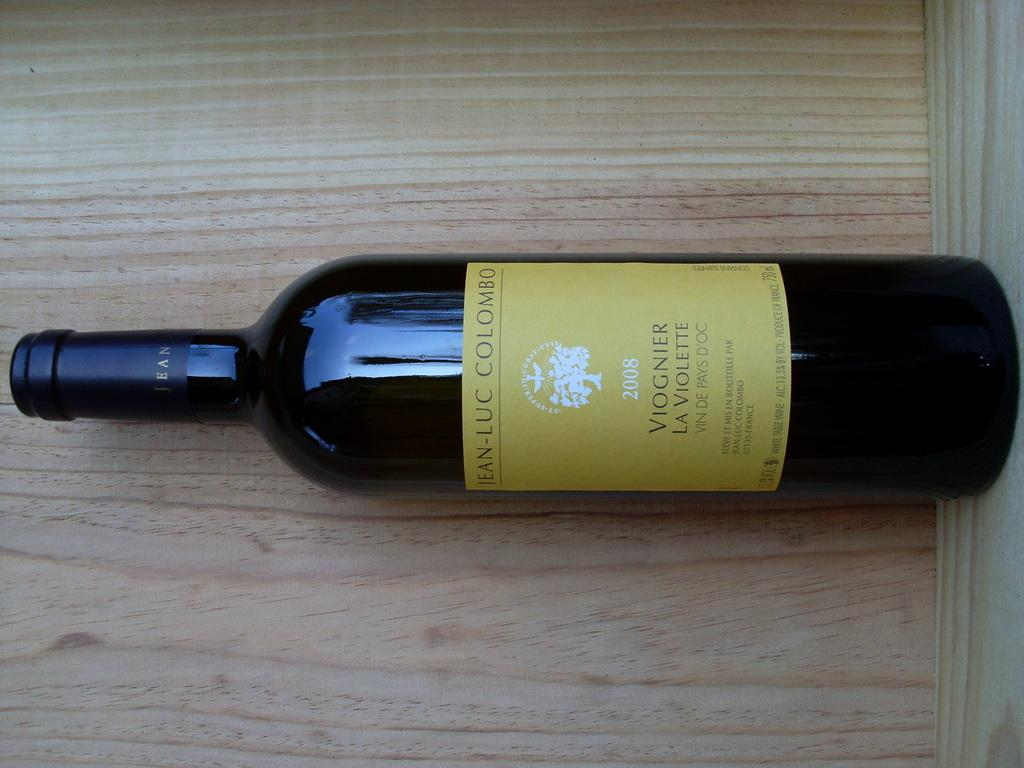<image>
Create a compact narrative representing the image presented. A bottle of Jean-Luc Colombo wine sits alone on a shelf. 